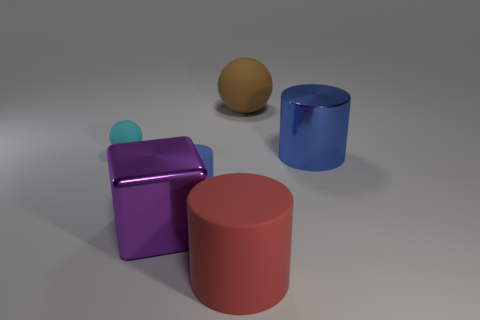What is the color of the metal thing that is the same size as the block?
Provide a short and direct response. Blue. Is there another large matte thing of the same shape as the cyan matte object?
Offer a terse response. Yes. What is the shape of the thing that is the same color as the big metal cylinder?
Offer a terse response. Cylinder. Is there a large blue object to the right of the tiny thing that is in front of the blue cylinder that is right of the tiny blue matte thing?
Make the answer very short. Yes. What shape is the purple metal thing that is the same size as the brown ball?
Make the answer very short. Cube. What is the color of the other matte thing that is the same shape as the big red object?
Give a very brief answer. Blue. How many objects are blue metallic blocks or large metallic objects?
Give a very brief answer. 2. There is a shiny thing that is to the left of the big brown rubber object; is its shape the same as the large shiny thing behind the large purple block?
Ensure brevity in your answer.  No. There is a big rubber object that is behind the metallic block; what is its shape?
Your answer should be very brief. Sphere. Are there the same number of cyan matte balls behind the cyan matte ball and red matte things that are behind the large brown rubber sphere?
Make the answer very short. Yes. 